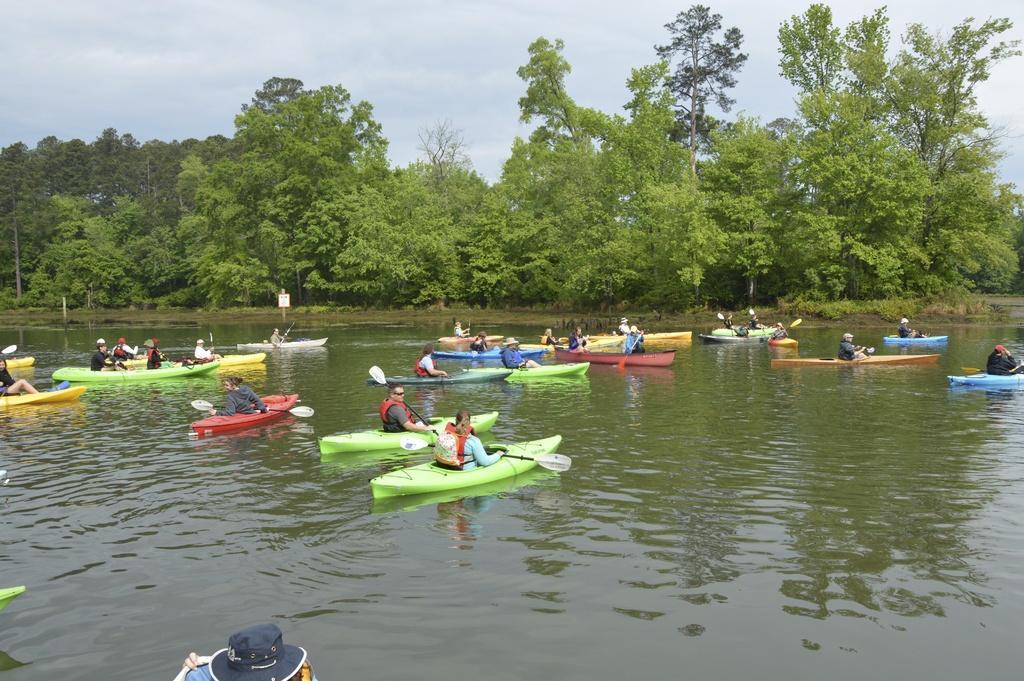In one or two sentences, can you explain what this image depicts? In this image there are a few people sitting on the inflatable boats, which are in the river. In the background there are trees and the sky. 